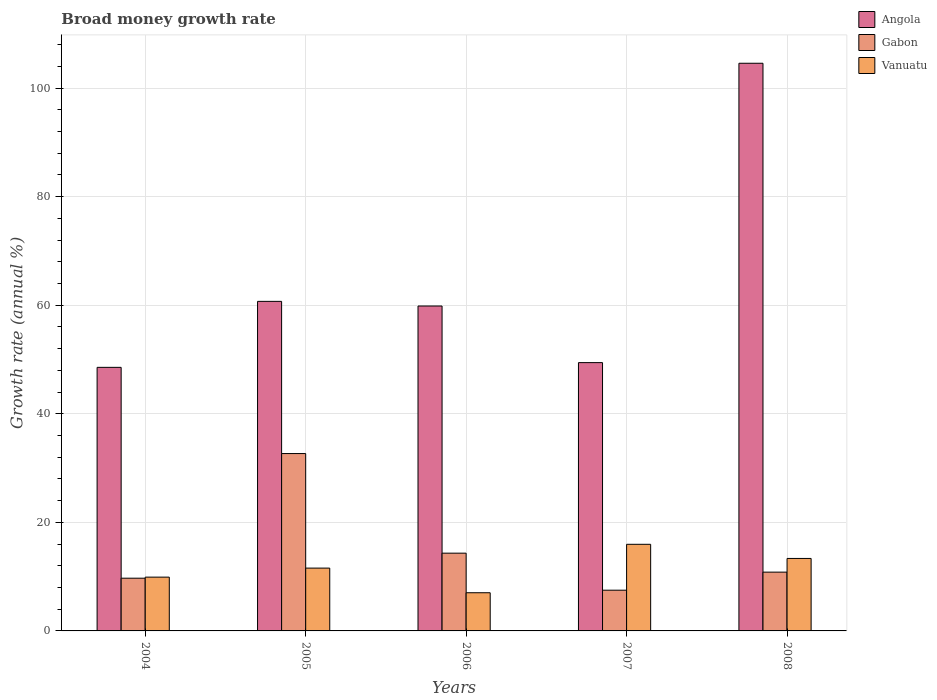Are the number of bars on each tick of the X-axis equal?
Give a very brief answer. Yes. How many bars are there on the 1st tick from the left?
Your response must be concise. 3. How many bars are there on the 1st tick from the right?
Give a very brief answer. 3. What is the label of the 1st group of bars from the left?
Keep it short and to the point. 2004. In how many cases, is the number of bars for a given year not equal to the number of legend labels?
Your response must be concise. 0. What is the growth rate in Angola in 2006?
Ensure brevity in your answer.  59.85. Across all years, what is the maximum growth rate in Gabon?
Offer a terse response. 32.67. Across all years, what is the minimum growth rate in Angola?
Give a very brief answer. 48.55. In which year was the growth rate in Vanuatu minimum?
Provide a short and direct response. 2006. What is the total growth rate in Vanuatu in the graph?
Keep it short and to the point. 57.82. What is the difference between the growth rate in Gabon in 2006 and that in 2007?
Make the answer very short. 6.82. What is the difference between the growth rate in Angola in 2008 and the growth rate in Gabon in 2005?
Make the answer very short. 71.89. What is the average growth rate in Angola per year?
Give a very brief answer. 64.62. In the year 2005, what is the difference between the growth rate in Angola and growth rate in Gabon?
Keep it short and to the point. 28.03. In how many years, is the growth rate in Angola greater than 56 %?
Provide a short and direct response. 3. What is the ratio of the growth rate in Gabon in 2006 to that in 2008?
Provide a short and direct response. 1.32. What is the difference between the highest and the second highest growth rate in Angola?
Give a very brief answer. 43.86. What is the difference between the highest and the lowest growth rate in Vanuatu?
Your response must be concise. 8.92. What does the 3rd bar from the left in 2005 represents?
Your response must be concise. Vanuatu. What does the 2nd bar from the right in 2008 represents?
Your answer should be compact. Gabon. How many years are there in the graph?
Provide a succinct answer. 5. Are the values on the major ticks of Y-axis written in scientific E-notation?
Your answer should be compact. No. What is the title of the graph?
Provide a succinct answer. Broad money growth rate. What is the label or title of the X-axis?
Ensure brevity in your answer.  Years. What is the label or title of the Y-axis?
Ensure brevity in your answer.  Growth rate (annual %). What is the Growth rate (annual %) in Angola in 2004?
Your response must be concise. 48.55. What is the Growth rate (annual %) in Gabon in 2004?
Your answer should be compact. 9.71. What is the Growth rate (annual %) of Vanuatu in 2004?
Ensure brevity in your answer.  9.91. What is the Growth rate (annual %) in Angola in 2005?
Keep it short and to the point. 60.71. What is the Growth rate (annual %) in Gabon in 2005?
Provide a short and direct response. 32.67. What is the Growth rate (annual %) in Vanuatu in 2005?
Provide a short and direct response. 11.57. What is the Growth rate (annual %) in Angola in 2006?
Your answer should be very brief. 59.85. What is the Growth rate (annual %) of Gabon in 2006?
Make the answer very short. 14.32. What is the Growth rate (annual %) of Vanuatu in 2006?
Provide a succinct answer. 7.03. What is the Growth rate (annual %) of Angola in 2007?
Offer a terse response. 49.42. What is the Growth rate (annual %) in Gabon in 2007?
Ensure brevity in your answer.  7.5. What is the Growth rate (annual %) in Vanuatu in 2007?
Offer a terse response. 15.96. What is the Growth rate (annual %) of Angola in 2008?
Provide a succinct answer. 104.57. What is the Growth rate (annual %) in Gabon in 2008?
Keep it short and to the point. 10.83. What is the Growth rate (annual %) of Vanuatu in 2008?
Your answer should be very brief. 13.35. Across all years, what is the maximum Growth rate (annual %) of Angola?
Give a very brief answer. 104.57. Across all years, what is the maximum Growth rate (annual %) in Gabon?
Give a very brief answer. 32.67. Across all years, what is the maximum Growth rate (annual %) in Vanuatu?
Your answer should be very brief. 15.96. Across all years, what is the minimum Growth rate (annual %) of Angola?
Keep it short and to the point. 48.55. Across all years, what is the minimum Growth rate (annual %) of Gabon?
Provide a succinct answer. 7.5. Across all years, what is the minimum Growth rate (annual %) of Vanuatu?
Provide a succinct answer. 7.03. What is the total Growth rate (annual %) of Angola in the graph?
Your answer should be compact. 323.1. What is the total Growth rate (annual %) of Gabon in the graph?
Your response must be concise. 75.04. What is the total Growth rate (annual %) of Vanuatu in the graph?
Keep it short and to the point. 57.82. What is the difference between the Growth rate (annual %) in Angola in 2004 and that in 2005?
Offer a terse response. -12.15. What is the difference between the Growth rate (annual %) of Gabon in 2004 and that in 2005?
Give a very brief answer. -22.96. What is the difference between the Growth rate (annual %) in Vanuatu in 2004 and that in 2005?
Your answer should be very brief. -1.66. What is the difference between the Growth rate (annual %) of Angola in 2004 and that in 2006?
Offer a terse response. -11.3. What is the difference between the Growth rate (annual %) of Gabon in 2004 and that in 2006?
Offer a terse response. -4.61. What is the difference between the Growth rate (annual %) of Vanuatu in 2004 and that in 2006?
Your response must be concise. 2.87. What is the difference between the Growth rate (annual %) in Angola in 2004 and that in 2007?
Offer a terse response. -0.87. What is the difference between the Growth rate (annual %) of Gabon in 2004 and that in 2007?
Offer a terse response. 2.21. What is the difference between the Growth rate (annual %) of Vanuatu in 2004 and that in 2007?
Offer a very short reply. -6.05. What is the difference between the Growth rate (annual %) of Angola in 2004 and that in 2008?
Offer a terse response. -56.01. What is the difference between the Growth rate (annual %) in Gabon in 2004 and that in 2008?
Offer a very short reply. -1.12. What is the difference between the Growth rate (annual %) of Vanuatu in 2004 and that in 2008?
Give a very brief answer. -3.44. What is the difference between the Growth rate (annual %) in Angola in 2005 and that in 2006?
Give a very brief answer. 0.86. What is the difference between the Growth rate (annual %) of Gabon in 2005 and that in 2006?
Offer a very short reply. 18.35. What is the difference between the Growth rate (annual %) of Vanuatu in 2005 and that in 2006?
Offer a terse response. 4.54. What is the difference between the Growth rate (annual %) in Angola in 2005 and that in 2007?
Make the answer very short. 11.28. What is the difference between the Growth rate (annual %) in Gabon in 2005 and that in 2007?
Give a very brief answer. 25.17. What is the difference between the Growth rate (annual %) in Vanuatu in 2005 and that in 2007?
Provide a short and direct response. -4.38. What is the difference between the Growth rate (annual %) in Angola in 2005 and that in 2008?
Your answer should be compact. -43.86. What is the difference between the Growth rate (annual %) in Gabon in 2005 and that in 2008?
Provide a short and direct response. 21.84. What is the difference between the Growth rate (annual %) in Vanuatu in 2005 and that in 2008?
Make the answer very short. -1.78. What is the difference between the Growth rate (annual %) in Angola in 2006 and that in 2007?
Provide a succinct answer. 10.43. What is the difference between the Growth rate (annual %) of Gabon in 2006 and that in 2007?
Your response must be concise. 6.82. What is the difference between the Growth rate (annual %) in Vanuatu in 2006 and that in 2007?
Provide a short and direct response. -8.92. What is the difference between the Growth rate (annual %) in Angola in 2006 and that in 2008?
Your answer should be very brief. -44.72. What is the difference between the Growth rate (annual %) in Gabon in 2006 and that in 2008?
Ensure brevity in your answer.  3.49. What is the difference between the Growth rate (annual %) in Vanuatu in 2006 and that in 2008?
Provide a short and direct response. -6.32. What is the difference between the Growth rate (annual %) of Angola in 2007 and that in 2008?
Make the answer very short. -55.14. What is the difference between the Growth rate (annual %) in Gabon in 2007 and that in 2008?
Provide a short and direct response. -3.33. What is the difference between the Growth rate (annual %) of Vanuatu in 2007 and that in 2008?
Ensure brevity in your answer.  2.61. What is the difference between the Growth rate (annual %) of Angola in 2004 and the Growth rate (annual %) of Gabon in 2005?
Keep it short and to the point. 15.88. What is the difference between the Growth rate (annual %) of Angola in 2004 and the Growth rate (annual %) of Vanuatu in 2005?
Provide a succinct answer. 36.98. What is the difference between the Growth rate (annual %) of Gabon in 2004 and the Growth rate (annual %) of Vanuatu in 2005?
Provide a short and direct response. -1.86. What is the difference between the Growth rate (annual %) in Angola in 2004 and the Growth rate (annual %) in Gabon in 2006?
Offer a terse response. 34.23. What is the difference between the Growth rate (annual %) of Angola in 2004 and the Growth rate (annual %) of Vanuatu in 2006?
Offer a terse response. 41.52. What is the difference between the Growth rate (annual %) of Gabon in 2004 and the Growth rate (annual %) of Vanuatu in 2006?
Offer a very short reply. 2.68. What is the difference between the Growth rate (annual %) in Angola in 2004 and the Growth rate (annual %) in Gabon in 2007?
Your response must be concise. 41.05. What is the difference between the Growth rate (annual %) in Angola in 2004 and the Growth rate (annual %) in Vanuatu in 2007?
Offer a very short reply. 32.6. What is the difference between the Growth rate (annual %) of Gabon in 2004 and the Growth rate (annual %) of Vanuatu in 2007?
Ensure brevity in your answer.  -6.24. What is the difference between the Growth rate (annual %) in Angola in 2004 and the Growth rate (annual %) in Gabon in 2008?
Keep it short and to the point. 37.72. What is the difference between the Growth rate (annual %) in Angola in 2004 and the Growth rate (annual %) in Vanuatu in 2008?
Ensure brevity in your answer.  35.2. What is the difference between the Growth rate (annual %) in Gabon in 2004 and the Growth rate (annual %) in Vanuatu in 2008?
Give a very brief answer. -3.64. What is the difference between the Growth rate (annual %) of Angola in 2005 and the Growth rate (annual %) of Gabon in 2006?
Your answer should be compact. 46.38. What is the difference between the Growth rate (annual %) of Angola in 2005 and the Growth rate (annual %) of Vanuatu in 2006?
Give a very brief answer. 53.67. What is the difference between the Growth rate (annual %) of Gabon in 2005 and the Growth rate (annual %) of Vanuatu in 2006?
Offer a terse response. 25.64. What is the difference between the Growth rate (annual %) of Angola in 2005 and the Growth rate (annual %) of Gabon in 2007?
Keep it short and to the point. 53.2. What is the difference between the Growth rate (annual %) in Angola in 2005 and the Growth rate (annual %) in Vanuatu in 2007?
Make the answer very short. 44.75. What is the difference between the Growth rate (annual %) of Gabon in 2005 and the Growth rate (annual %) of Vanuatu in 2007?
Provide a succinct answer. 16.72. What is the difference between the Growth rate (annual %) in Angola in 2005 and the Growth rate (annual %) in Gabon in 2008?
Your answer should be very brief. 49.88. What is the difference between the Growth rate (annual %) of Angola in 2005 and the Growth rate (annual %) of Vanuatu in 2008?
Keep it short and to the point. 47.35. What is the difference between the Growth rate (annual %) in Gabon in 2005 and the Growth rate (annual %) in Vanuatu in 2008?
Make the answer very short. 19.32. What is the difference between the Growth rate (annual %) in Angola in 2006 and the Growth rate (annual %) in Gabon in 2007?
Ensure brevity in your answer.  52.35. What is the difference between the Growth rate (annual %) of Angola in 2006 and the Growth rate (annual %) of Vanuatu in 2007?
Offer a terse response. 43.89. What is the difference between the Growth rate (annual %) of Gabon in 2006 and the Growth rate (annual %) of Vanuatu in 2007?
Provide a succinct answer. -1.63. What is the difference between the Growth rate (annual %) in Angola in 2006 and the Growth rate (annual %) in Gabon in 2008?
Give a very brief answer. 49.02. What is the difference between the Growth rate (annual %) of Angola in 2006 and the Growth rate (annual %) of Vanuatu in 2008?
Keep it short and to the point. 46.5. What is the difference between the Growth rate (annual %) in Angola in 2007 and the Growth rate (annual %) in Gabon in 2008?
Make the answer very short. 38.59. What is the difference between the Growth rate (annual %) of Angola in 2007 and the Growth rate (annual %) of Vanuatu in 2008?
Keep it short and to the point. 36.07. What is the difference between the Growth rate (annual %) in Gabon in 2007 and the Growth rate (annual %) in Vanuatu in 2008?
Provide a short and direct response. -5.85. What is the average Growth rate (annual %) of Angola per year?
Ensure brevity in your answer.  64.62. What is the average Growth rate (annual %) in Gabon per year?
Ensure brevity in your answer.  15.01. What is the average Growth rate (annual %) of Vanuatu per year?
Your response must be concise. 11.56. In the year 2004, what is the difference between the Growth rate (annual %) in Angola and Growth rate (annual %) in Gabon?
Provide a short and direct response. 38.84. In the year 2004, what is the difference between the Growth rate (annual %) of Angola and Growth rate (annual %) of Vanuatu?
Make the answer very short. 38.64. In the year 2004, what is the difference between the Growth rate (annual %) in Gabon and Growth rate (annual %) in Vanuatu?
Keep it short and to the point. -0.19. In the year 2005, what is the difference between the Growth rate (annual %) in Angola and Growth rate (annual %) in Gabon?
Keep it short and to the point. 28.03. In the year 2005, what is the difference between the Growth rate (annual %) of Angola and Growth rate (annual %) of Vanuatu?
Give a very brief answer. 49.13. In the year 2005, what is the difference between the Growth rate (annual %) of Gabon and Growth rate (annual %) of Vanuatu?
Provide a succinct answer. 21.1. In the year 2006, what is the difference between the Growth rate (annual %) in Angola and Growth rate (annual %) in Gabon?
Your response must be concise. 45.53. In the year 2006, what is the difference between the Growth rate (annual %) of Angola and Growth rate (annual %) of Vanuatu?
Provide a short and direct response. 52.82. In the year 2006, what is the difference between the Growth rate (annual %) in Gabon and Growth rate (annual %) in Vanuatu?
Your answer should be very brief. 7.29. In the year 2007, what is the difference between the Growth rate (annual %) of Angola and Growth rate (annual %) of Gabon?
Your response must be concise. 41.92. In the year 2007, what is the difference between the Growth rate (annual %) of Angola and Growth rate (annual %) of Vanuatu?
Offer a very short reply. 33.47. In the year 2007, what is the difference between the Growth rate (annual %) in Gabon and Growth rate (annual %) in Vanuatu?
Offer a very short reply. -8.45. In the year 2008, what is the difference between the Growth rate (annual %) in Angola and Growth rate (annual %) in Gabon?
Provide a succinct answer. 93.74. In the year 2008, what is the difference between the Growth rate (annual %) of Angola and Growth rate (annual %) of Vanuatu?
Give a very brief answer. 91.21. In the year 2008, what is the difference between the Growth rate (annual %) in Gabon and Growth rate (annual %) in Vanuatu?
Offer a terse response. -2.52. What is the ratio of the Growth rate (annual %) of Angola in 2004 to that in 2005?
Keep it short and to the point. 0.8. What is the ratio of the Growth rate (annual %) of Gabon in 2004 to that in 2005?
Provide a short and direct response. 0.3. What is the ratio of the Growth rate (annual %) in Vanuatu in 2004 to that in 2005?
Make the answer very short. 0.86. What is the ratio of the Growth rate (annual %) in Angola in 2004 to that in 2006?
Provide a succinct answer. 0.81. What is the ratio of the Growth rate (annual %) of Gabon in 2004 to that in 2006?
Ensure brevity in your answer.  0.68. What is the ratio of the Growth rate (annual %) in Vanuatu in 2004 to that in 2006?
Give a very brief answer. 1.41. What is the ratio of the Growth rate (annual %) in Angola in 2004 to that in 2007?
Make the answer very short. 0.98. What is the ratio of the Growth rate (annual %) in Gabon in 2004 to that in 2007?
Offer a very short reply. 1.29. What is the ratio of the Growth rate (annual %) in Vanuatu in 2004 to that in 2007?
Keep it short and to the point. 0.62. What is the ratio of the Growth rate (annual %) of Angola in 2004 to that in 2008?
Make the answer very short. 0.46. What is the ratio of the Growth rate (annual %) in Gabon in 2004 to that in 2008?
Your response must be concise. 0.9. What is the ratio of the Growth rate (annual %) in Vanuatu in 2004 to that in 2008?
Offer a terse response. 0.74. What is the ratio of the Growth rate (annual %) in Angola in 2005 to that in 2006?
Give a very brief answer. 1.01. What is the ratio of the Growth rate (annual %) of Gabon in 2005 to that in 2006?
Give a very brief answer. 2.28. What is the ratio of the Growth rate (annual %) of Vanuatu in 2005 to that in 2006?
Provide a short and direct response. 1.65. What is the ratio of the Growth rate (annual %) of Angola in 2005 to that in 2007?
Your answer should be compact. 1.23. What is the ratio of the Growth rate (annual %) in Gabon in 2005 to that in 2007?
Your answer should be very brief. 4.36. What is the ratio of the Growth rate (annual %) in Vanuatu in 2005 to that in 2007?
Make the answer very short. 0.73. What is the ratio of the Growth rate (annual %) in Angola in 2005 to that in 2008?
Keep it short and to the point. 0.58. What is the ratio of the Growth rate (annual %) in Gabon in 2005 to that in 2008?
Ensure brevity in your answer.  3.02. What is the ratio of the Growth rate (annual %) in Vanuatu in 2005 to that in 2008?
Offer a terse response. 0.87. What is the ratio of the Growth rate (annual %) in Angola in 2006 to that in 2007?
Give a very brief answer. 1.21. What is the ratio of the Growth rate (annual %) in Gabon in 2006 to that in 2007?
Offer a terse response. 1.91. What is the ratio of the Growth rate (annual %) in Vanuatu in 2006 to that in 2007?
Your answer should be compact. 0.44. What is the ratio of the Growth rate (annual %) of Angola in 2006 to that in 2008?
Give a very brief answer. 0.57. What is the ratio of the Growth rate (annual %) of Gabon in 2006 to that in 2008?
Your response must be concise. 1.32. What is the ratio of the Growth rate (annual %) in Vanuatu in 2006 to that in 2008?
Give a very brief answer. 0.53. What is the ratio of the Growth rate (annual %) in Angola in 2007 to that in 2008?
Your response must be concise. 0.47. What is the ratio of the Growth rate (annual %) of Gabon in 2007 to that in 2008?
Offer a very short reply. 0.69. What is the ratio of the Growth rate (annual %) of Vanuatu in 2007 to that in 2008?
Make the answer very short. 1.2. What is the difference between the highest and the second highest Growth rate (annual %) of Angola?
Give a very brief answer. 43.86. What is the difference between the highest and the second highest Growth rate (annual %) in Gabon?
Your answer should be compact. 18.35. What is the difference between the highest and the second highest Growth rate (annual %) in Vanuatu?
Your answer should be very brief. 2.61. What is the difference between the highest and the lowest Growth rate (annual %) in Angola?
Your answer should be compact. 56.01. What is the difference between the highest and the lowest Growth rate (annual %) in Gabon?
Your answer should be very brief. 25.17. What is the difference between the highest and the lowest Growth rate (annual %) of Vanuatu?
Provide a short and direct response. 8.92. 